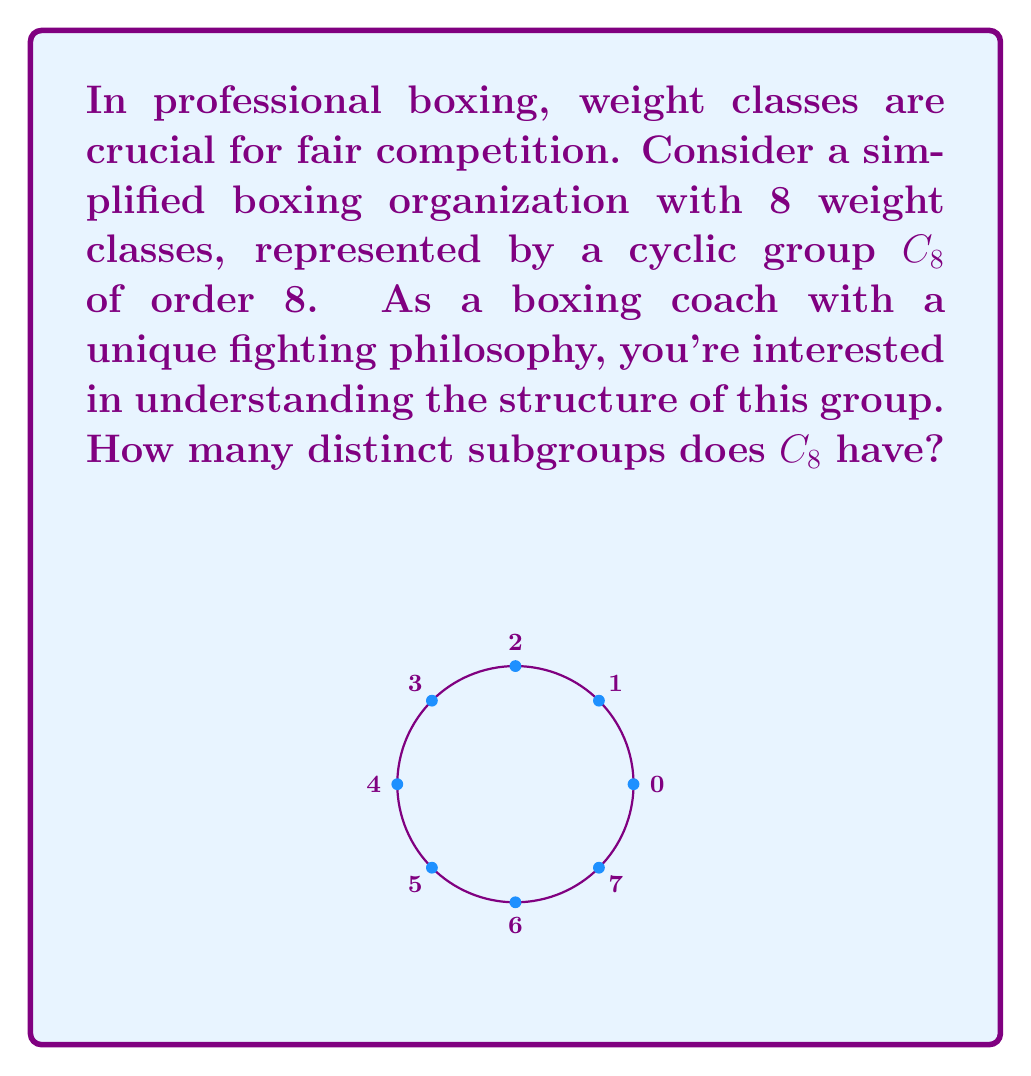Give your solution to this math problem. To find the number of distinct subgroups in $C_8$, we follow these steps:

1) In a cyclic group $C_n$, the subgroups correspond to the divisors of $n$.

2) The divisors of 8 are: 1, 2, 4, and 8.

3) For each divisor $d$, there is exactly one subgroup of order $d$.

4) Let's identify these subgroups:
   - Order 1: $\{0\}$ (the trivial subgroup)
   - Order 2: $\{0, 4\}$
   - Order 4: $\{0, 2, 4, 6\}$
   - Order 8: $\{0, 1, 2, 3, 4, 5, 6, 7\}$ (the entire group)

5) Therefore, the number of distinct subgroups is equal to the number of divisors of 8.

6) Count the divisors: 1, 2, 4, 8.

Thus, $C_8$ has 4 distinct subgroups.

This structure reflects the hierarchical nature of weight classes, where boxers might move between adjacent classes or skip multiple classes, represented by the various subgroups.
Answer: 4 